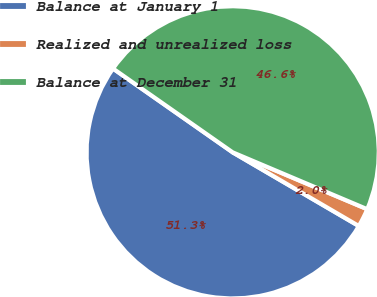Convert chart to OTSL. <chart><loc_0><loc_0><loc_500><loc_500><pie_chart><fcel>Balance at January 1<fcel>Realized and unrealized loss<fcel>Balance at December 31<nl><fcel>51.31%<fcel>2.05%<fcel>46.64%<nl></chart> 